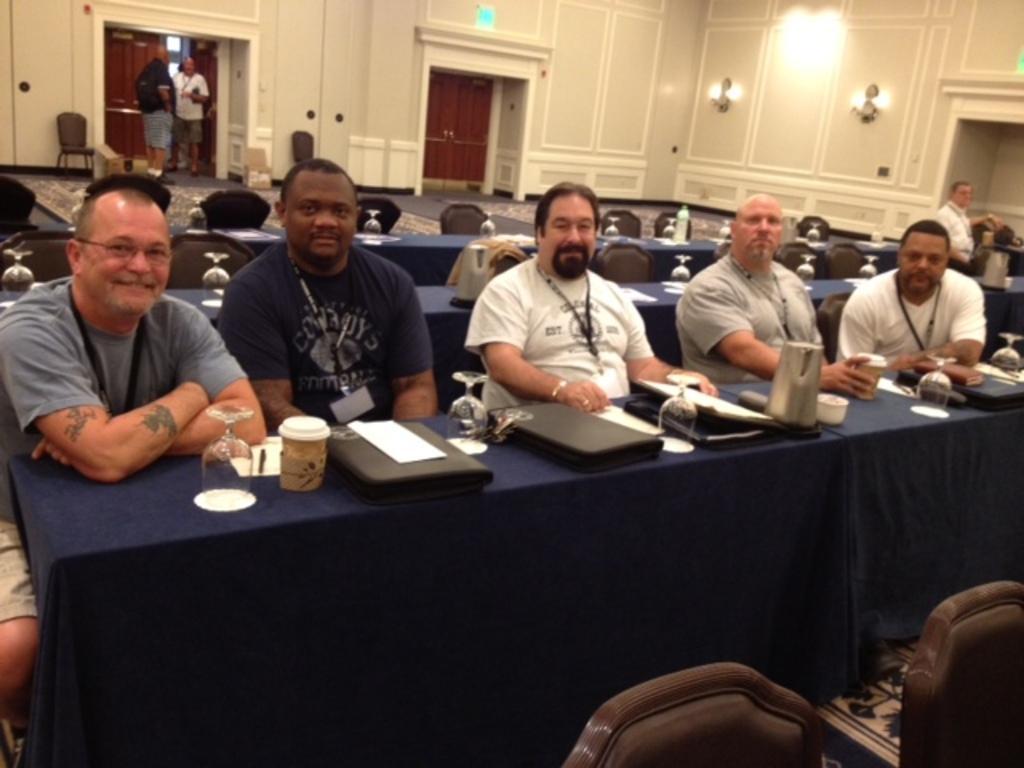How would you summarize this image in a sentence or two? This is a picture taken in a room, there are a group of people sitting on chairs in front of these people there is a table covered with a cloth on the table there are glasses, jar, files and paper. Behind the people there are some tables, chairs and there are two other people standing near to the door and a wall on the wall there are lights. 